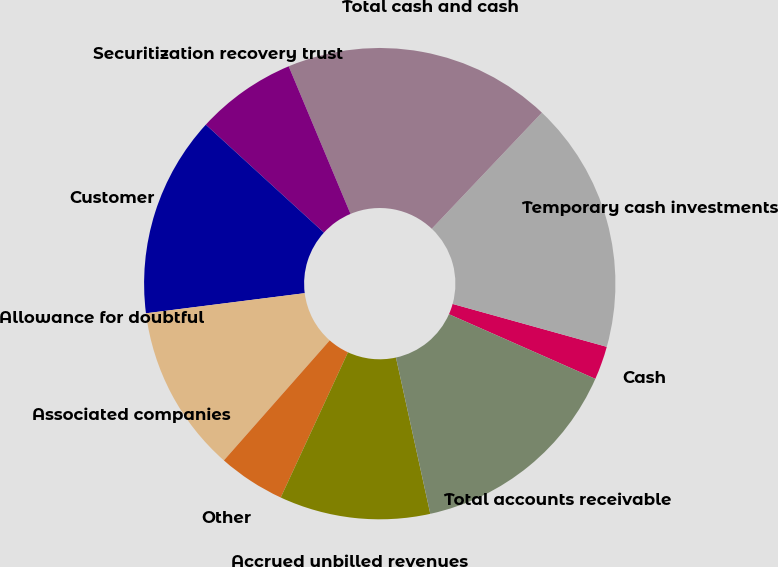Convert chart. <chart><loc_0><loc_0><loc_500><loc_500><pie_chart><fcel>Cash<fcel>Temporary cash investments<fcel>Total cash and cash<fcel>Securitization recovery trust<fcel>Customer<fcel>Allowance for doubtful<fcel>Associated companies<fcel>Other<fcel>Accrued unbilled revenues<fcel>Total accounts receivable<nl><fcel>2.3%<fcel>17.24%<fcel>18.39%<fcel>6.9%<fcel>13.79%<fcel>0.0%<fcel>11.49%<fcel>4.6%<fcel>10.34%<fcel>14.94%<nl></chart> 